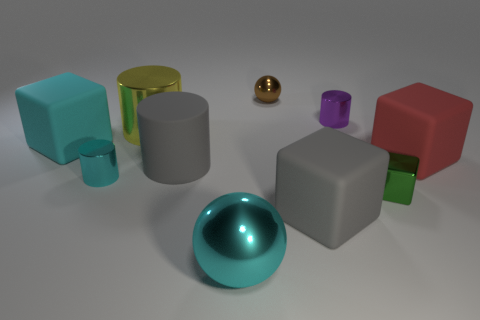Subtract all tiny cyan shiny cylinders. How many cylinders are left? 3 Subtract 1 cubes. How many cubes are left? 3 Subtract all red cylinders. Subtract all green cubes. How many cylinders are left? 4 Subtract all balls. How many objects are left? 8 Subtract 0 gray spheres. How many objects are left? 10 Subtract all small brown things. Subtract all metallic cylinders. How many objects are left? 6 Add 8 large red objects. How many large red objects are left? 9 Add 3 tiny brown metal things. How many tiny brown metal things exist? 4 